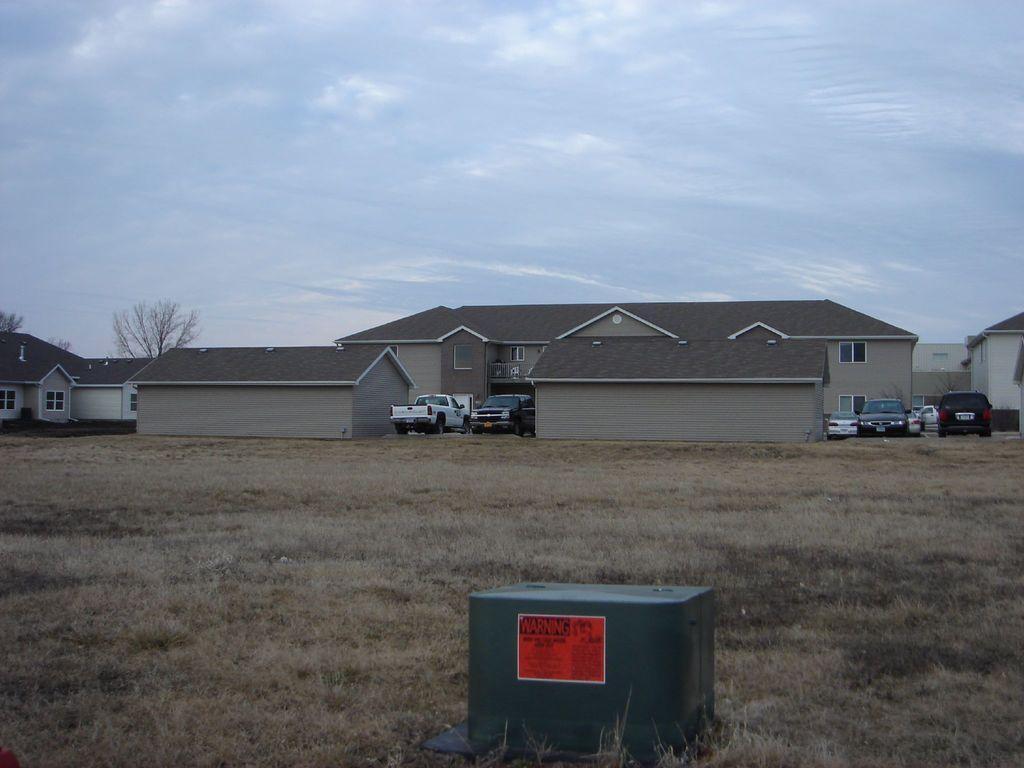Could you give a brief overview of what you see in this image? In this picture there is an object which has an orange color paper attached on it and there are few vehicles and houses in the background and the sky is cloudy. 